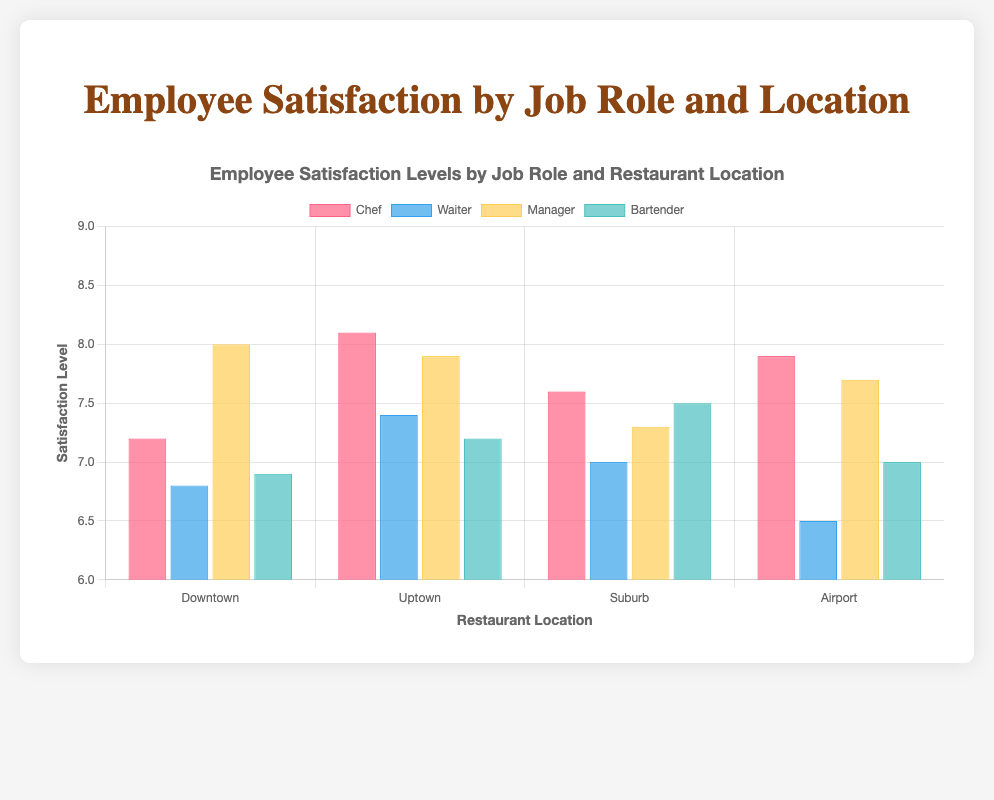What is the average satisfaction level of Managers across all restaurant locations? First, find the satisfaction levels of Managers at each location: Downtown (8.0), Uptown (7.9), Suburb (7.3), Airport (7.7). Sum these values: 8.0 + 7.9 + 7.3 + 7.7 = 30.9. Then, divide by the number of locations (4): 30.9 / 4 = 7.725.
Answer: 7.725 Which job role has the highest satisfaction level at the Downtown location? Look at the satisfaction levels for each job role at the Downtown location: Chef (7.2), Waiter (6.8), Manager (8.0), Bartender (6.9). The highest value is for the Manager, with a satisfaction level of 8.0.
Answer: Manager At which location do Waiters have the lowest satisfaction level? Compare the satisfaction levels of Waiters across locations: Downtown (6.8), Uptown (7.4), Suburb (7.0), Airport (6.5). The lowest satisfaction level is at the Airport location, with 6.5.
Answer: Airport Is the satisfaction level of Chefs higher in Uptown or Suburb? Compare the satisfaction levels for Chefs: Uptown (8.1), Suburb (7.6). The satisfaction level is higher in Uptown.
Answer: Uptown Which location has the most consistent satisfaction levels across all job roles? Check the range of satisfaction levels for each location:
- Downtown: 6.8 (Waiter) to 8.0 (Manager) -> Range = 1.2
- Uptown: 7.2 (Bartender) to 8.1 (Chef) -> Range = 0.9
- Suburb: 7.0 (Waiter) to 7.6 (Chef) -> Range = 0.6
- Airport: 6.5 (Waiter) to 7.9 (Chef) -> Range = 1.4
The Suburb has the smallest range, indicating the most consistent satisfaction levels.
Answer: Suburb By how much does the satisfaction level of Waiters at Uptown exceed that at Downtown? The satisfaction levels are Uptown (7.4) and Downtown (6.8). Subtract the Downtown value from the Uptown value: 7.4 - 6.8 = 0.6.
Answer: 0.6 Which job role at the Airport location has a satisfaction level that is closest to the overall average satisfaction level of that location? Calculate the overall average satisfaction level at the Airport: (7.9 + 6.5 + 7.7 + 7.0) / 4 = 7.275. Compare each role's satisfaction to this average:
- Chef: 7.9 -> Difference = 0.625
- Waiter: 6.5 -> Difference = 0.775
- Manager: 7.7 -> Difference = 0.425
- Bartender: 7.0 -> Difference = 0.275
The Bartender's level (7.0) is nearest to 7.275.
Answer: Bartender Where is the difference between the highest and lowest satisfaction level the greatest? Calculate the ranges for each location:
- Downtown: 8.0 - 6.8 = 1.2
- Uptown: 8.1 - 7.2 = 0.9
- Suburb: 7.6 - 7.0 = 0.6
- Airport: 7.9 - 6.5 = 1.4
The largest difference is at the Airport location.
Answer: Airport 